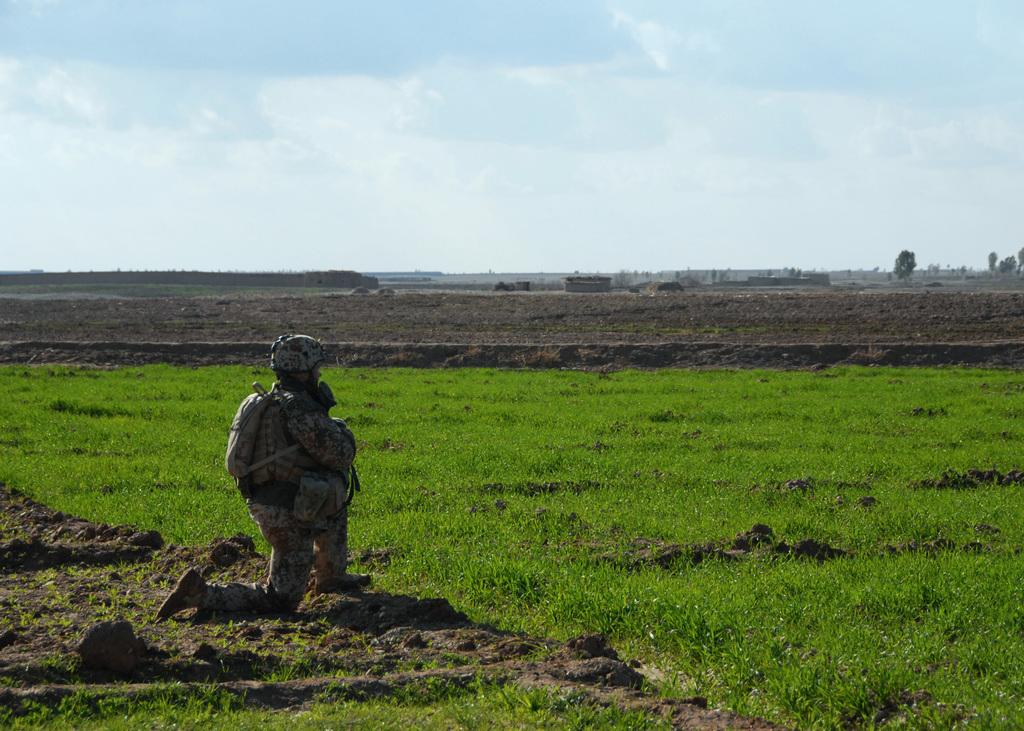What is the person in the image doing? The person in the image is in a squat position and carrying a bag. What can be seen on the ground in the image? The ground is visible in the image, with some soil and green grass. What is visible in the sky in the image? The sky is visible in the image. What type of vegetation is present in the image? There are trees present in the image. What type of amusement can be seen in the image? There is no amusement present in the image; it features a person in a squat position carrying a bag, the ground, sky, and trees. What type of beast is interacting with the person in the image? There is no beast present in the image; it only features a person in a squat position carrying a bag, the ground, sky, and trees. 